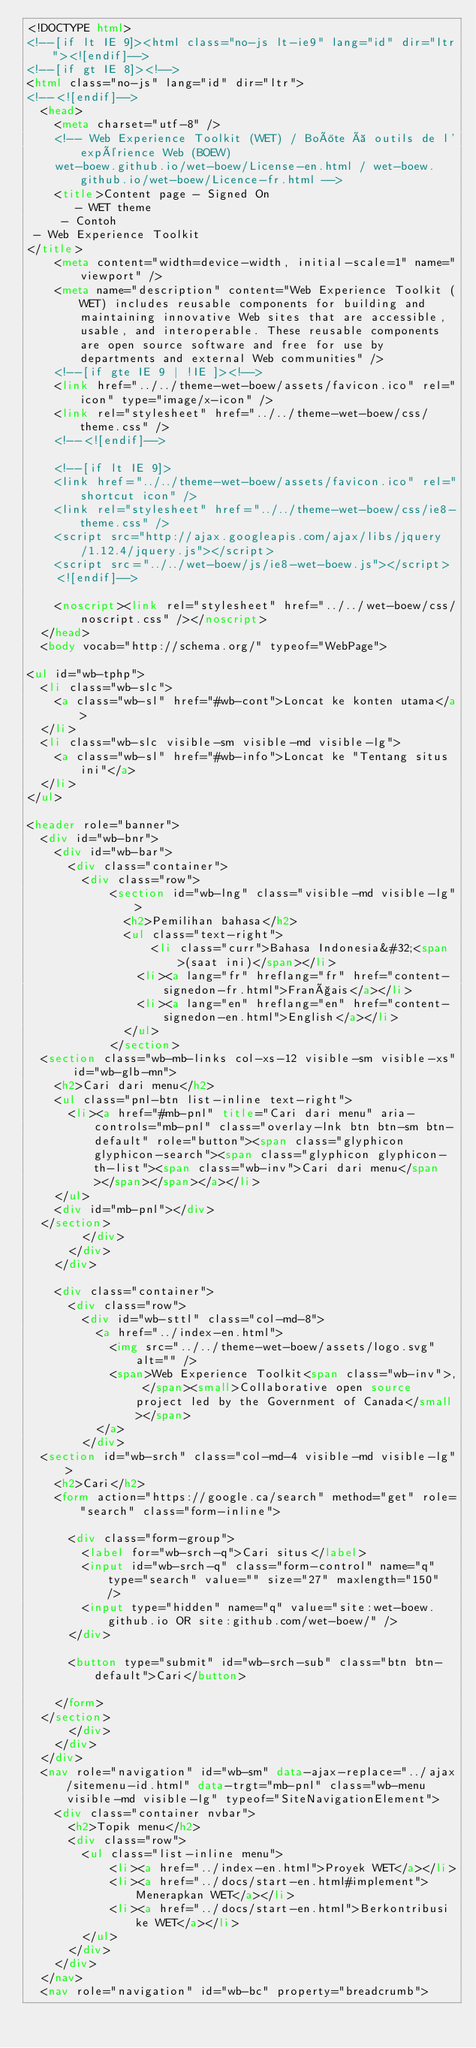<code> <loc_0><loc_0><loc_500><loc_500><_HTML_><!DOCTYPE html>
<!--[if lt IE 9]><html class="no-js lt-ie9" lang="id" dir="ltr"><![endif]-->
<!--[if gt IE 8]><!-->
<html class="no-js" lang="id" dir="ltr">
<!--<![endif]-->
	<head>
		<meta charset="utf-8" />
		<!-- Web Experience Toolkit (WET) / Boîte à outils de l'expérience Web (BOEW)
		wet-boew.github.io/wet-boew/License-en.html / wet-boew.github.io/wet-boew/Licence-fr.html -->
		<title>Content page - Signed On
			 - WET theme
		 - Contoh 
 - Web Experience Toolkit
</title>
		<meta content="width=device-width, initial-scale=1" name="viewport" />
		<meta name="description" content="Web Experience Toolkit (WET) includes reusable components for building and maintaining innovative Web sites that are accessible, usable, and interoperable. These reusable components are open source software and free for use by departments and external Web communities" />
		<!--[if gte IE 9 | !IE ]><!-->
		<link href="../../theme-wet-boew/assets/favicon.ico" rel="icon" type="image/x-icon" />
		<link rel="stylesheet" href="../../theme-wet-boew/css/theme.css" />
		<!--<![endif]-->
		
		<!--[if lt IE 9]>
		<link href="../../theme-wet-boew/assets/favicon.ico" rel="shortcut icon" />
		<link rel="stylesheet" href="../../theme-wet-boew/css/ie8-theme.css" />
		<script src="http://ajax.googleapis.com/ajax/libs/jquery/1.12.4/jquery.js"></script>
		<script src="../../wet-boew/js/ie8-wet-boew.js"></script>
		<![endif]-->
		
		<noscript><link rel="stylesheet" href="../../wet-boew/css/noscript.css" /></noscript>
	</head>
	<body vocab="http://schema.org/" typeof="WebPage">
		
<ul id="wb-tphp">
	<li class="wb-slc">
		<a class="wb-sl" href="#wb-cont">Loncat ke konten utama</a>
	</li>
	<li class="wb-slc visible-sm visible-md visible-lg">
		<a class="wb-sl" href="#wb-info">Loncat ke "Tentang situs ini"</a>
	</li>
</ul>

<header role="banner">
	<div id="wb-bnr">
		<div id="wb-bar">
			<div class="container">
				<div class="row">
						<section id="wb-lng" class="visible-md visible-lg">
							<h2>Pemilihan bahasa</h2>
							<ul class="text-right">
									<li class="curr">Bahasa Indonesia&#32;<span>(saat ini)</span></li>
								<li><a lang="fr" hreflang="fr" href="content-signedon-fr.html">Français</a></li>
								<li><a lang="en" hreflang="en" href="content-signedon-en.html">English</a></li>
							</ul>
						</section>
	<section class="wb-mb-links col-xs-12 visible-sm visible-xs" id="wb-glb-mn">
		<h2>Cari dari menu</h2>
		<ul class="pnl-btn list-inline text-right">
			<li><a href="#mb-pnl" title="Cari dari menu" aria-controls="mb-pnl" class="overlay-lnk btn btn-sm btn-default" role="button"><span class="glyphicon glyphicon-search"><span class="glyphicon glyphicon-th-list"><span class="wb-inv">Cari dari menu</span></span></span></a></li>
		</ul>
		<div id="mb-pnl"></div>
	</section>
				</div>
			</div>
		</div>

		<div class="container">
			<div class="row">
				<div id="wb-sttl" class="col-md-8">
					<a href="../index-en.html">
						<img src="../../theme-wet-boew/assets/logo.svg" alt="" />
						<span>Web Experience Toolkit<span class="wb-inv">, </span><small>Collaborative open source project led by the Government of Canada</small></span>
					</a>
				</div>
	<section id="wb-srch" class="col-md-4 visible-md visible-lg">
		<h2>Cari</h2>
		<form action="https://google.ca/search" method="get" role="search" class="form-inline">
	
			<div class="form-group">
				<label for="wb-srch-q">Cari situs</label>
				<input id="wb-srch-q" class="form-control" name="q" type="search" value="" size="27" maxlength="150" />
				<input type="hidden" name="q" value="site:wet-boew.github.io OR site:github.com/wet-boew/" />
			</div>
	
			<button type="submit" id="wb-srch-sub" class="btn btn-default">Cari</button>
	
		</form>
	</section>
			</div>
		</div>
	</div>
	<nav role="navigation" id="wb-sm" data-ajax-replace="../ajax/sitemenu-id.html" data-trgt="mb-pnl" class="wb-menu visible-md visible-lg" typeof="SiteNavigationElement">
		<div class="container nvbar">
			<h2>Topik menu</h2>
			<div class="row">
				<ul class="list-inline menu">
						<li><a href="../index-en.html">Proyek WET</a></li>
						<li><a href="../docs/start-en.html#implement">Menerapkan WET</a></li>
						<li><a href="../docs/start-en.html">Berkontribusi ke WET</a></li>
				</ul>
			</div>
		</div>
	</nav>
	<nav role="navigation" id="wb-bc" property="breadcrumb"></code> 